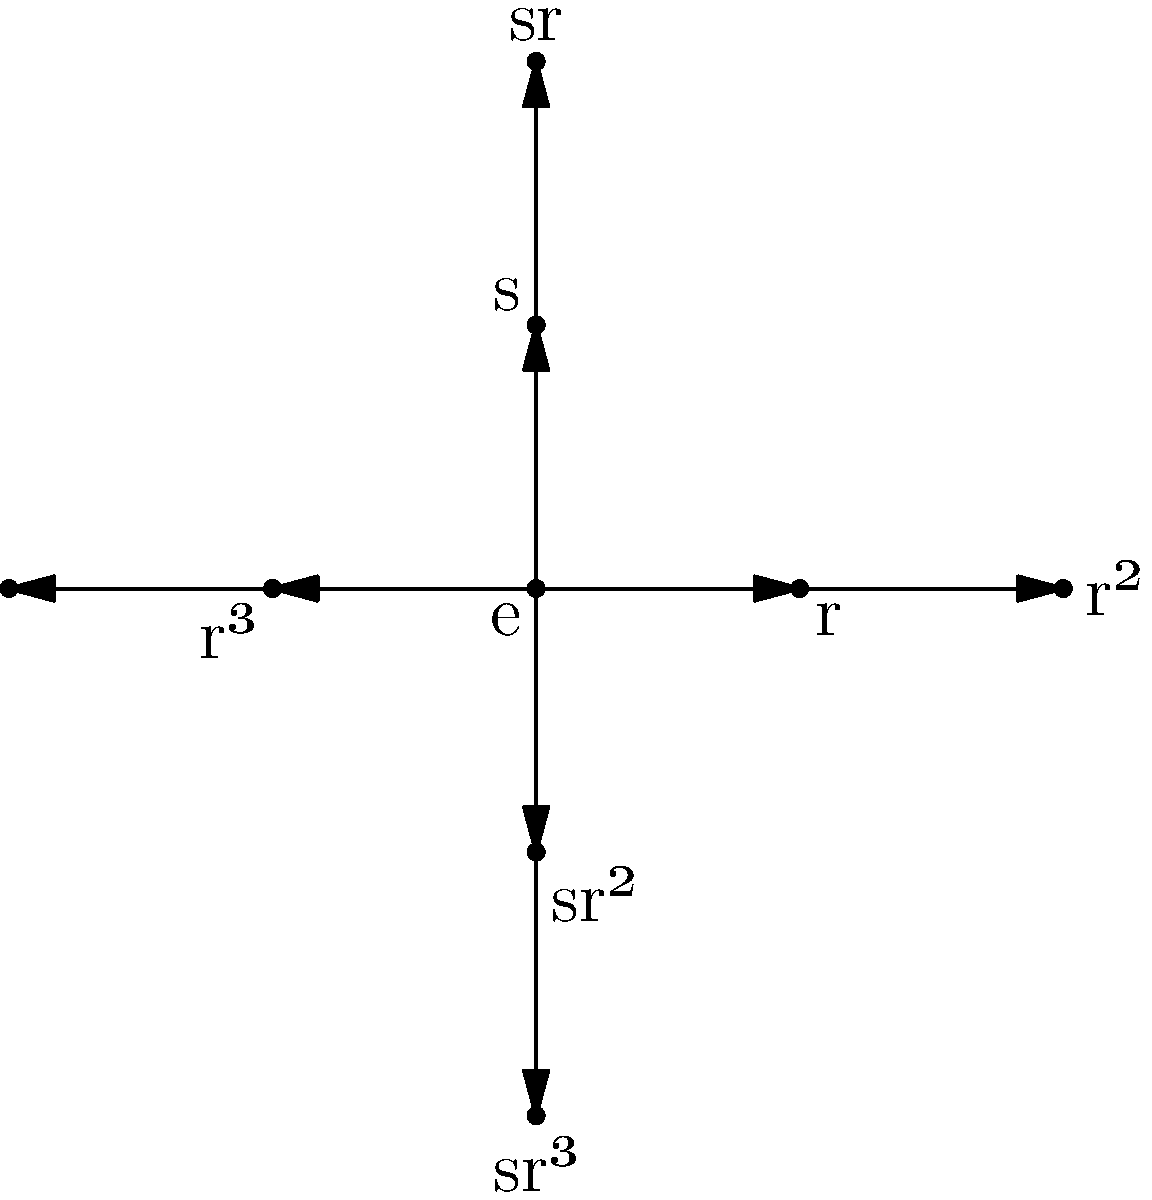Consider the Cayley graph of the dihedral group $D_4$ shown above. If you start at the identity element $e$ and perform the operation $sr^2s$, at which element will you end up? Express your answer in terms of the generators $r$ and $s$. Let's follow the path step-by-step:

1) We start at the identity element $e$.

2) First, we apply $s$:
   $e \rightarrow s$
   This moves us from $e$ to the vertex labeled $s$.

3) Next, we apply $r^2$:
   $s \rightarrow sr^2$
   This moves us from $s$ to the vertex labeled $sr^2$.

4) Finally, we apply $s$ again:
   $sr^2 \rightarrow sr^2s$

Now, we need to simplify $sr^2s$:

5) In $D_4$, we know that $s^2 = e$ and $srs = r^{-1} = r^3$.

6) Therefore, $sr^2s = s(r^2)s = (sr)(rs) = r^3r = r^4 = e$

So, after performing $sr^2s$, we end up back at the identity element $e$.
Answer: $e$ 